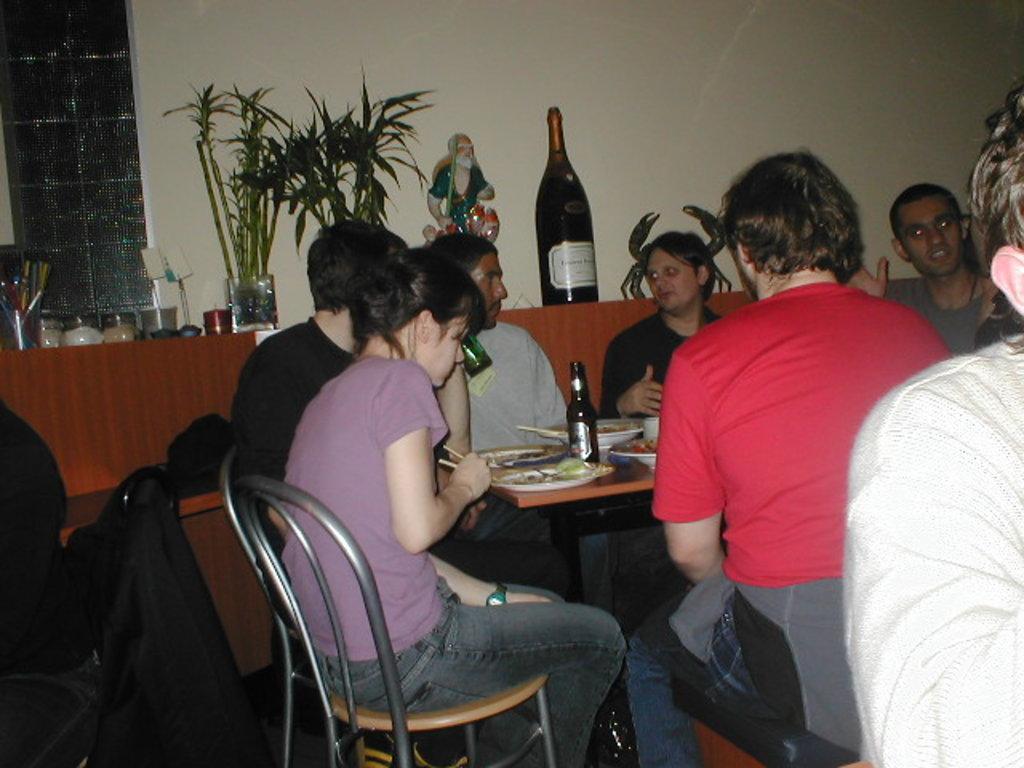Please provide a concise description of this image. In this picture we can see some people sitting on the chairs around the table. On the table there is a plate, bottle. And on the background we can see a wall. This is the bottle and these are the plants. 